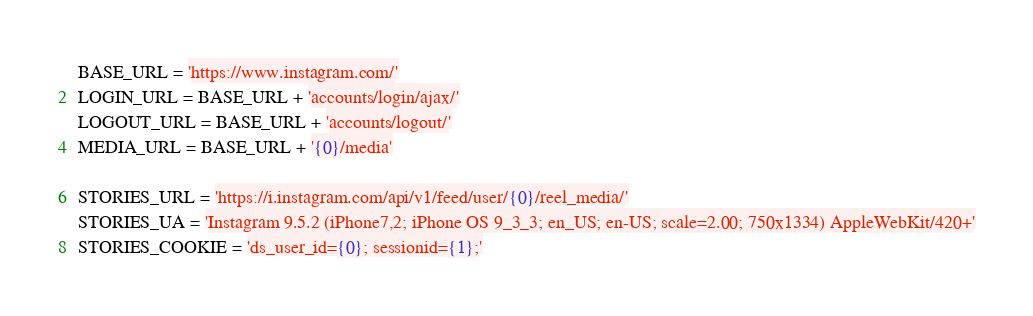Convert code to text. <code><loc_0><loc_0><loc_500><loc_500><_Python_>BASE_URL = 'https://www.instagram.com/'
LOGIN_URL = BASE_URL + 'accounts/login/ajax/'
LOGOUT_URL = BASE_URL + 'accounts/logout/'
MEDIA_URL = BASE_URL + '{0}/media'

STORIES_URL = 'https://i.instagram.com/api/v1/feed/user/{0}/reel_media/'
STORIES_UA = 'Instagram 9.5.2 (iPhone7,2; iPhone OS 9_3_3; en_US; en-US; scale=2.00; 750x1334) AppleWebKit/420+'
STORIES_COOKIE = 'ds_user_id={0}; sessionid={1};'
</code> 